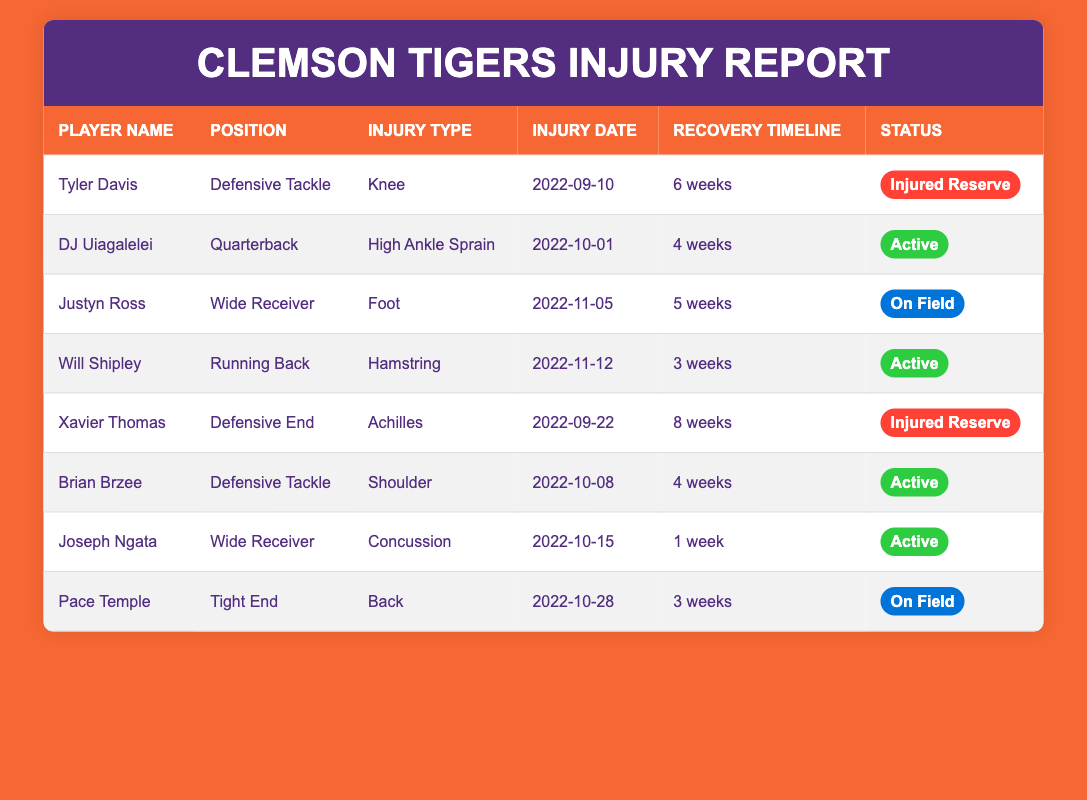What is the injury type for Tyler Davis? Tyler Davis's row shows that his injury type is labeled "Knee" under the Injury Type column.
Answer: Knee How long is the recovery timeline for Xavier Thomas? The recovery timeline for Xavier Thomas, indicated in the Recovery Timeline column, is "8 weeks".
Answer: 8 weeks Was Joseph Ngata's status active after his concussion? Joseph Ngata's status is listed as "Active" in the Status column. Thus, the answer is yes.
Answer: Yes Which player has suffered a high ankle sprain? The row for DJ Uiagalelei indicates that he suffered from a "High Ankle Sprain" in the Injury Type column.
Answer: DJ Uiagalelei What is the average recovery time of the players listed as active? The recovery timelines for active players are: DJ Uiagalelei (4 weeks), Brian Brzee (4 weeks), Joseph Ngata (1 week), and Will Shipley (3 weeks). The total recovery time adds up to 12 weeks, divided by 4 gives an average of 3 weeks.
Answer: 3 weeks Is Justyn Ross currently on the field? Justyn Ross is marked as "On Field" in the Status column. Thus, the answer is yes.
Answer: Yes Which player had the shortest recovery time, and what was it? The recovery timelines for all players show that Joseph Ngata with "1 week" has the shortest recovery time.
Answer: Joseph Ngata, 1 week What is the combined recovery time of all players on injured reserve? Tyler Davis's recovery time is 6 weeks, and Xavier Thomas's is 8 weeks, totaling 14 weeks.
Answer: 14 weeks Did any players return from injuries in 3 weeks? Yes, both Will Shipley and Pace Temple have a recovery timeline of "3 weeks", indicating they will return in that timeframe.
Answer: Yes 